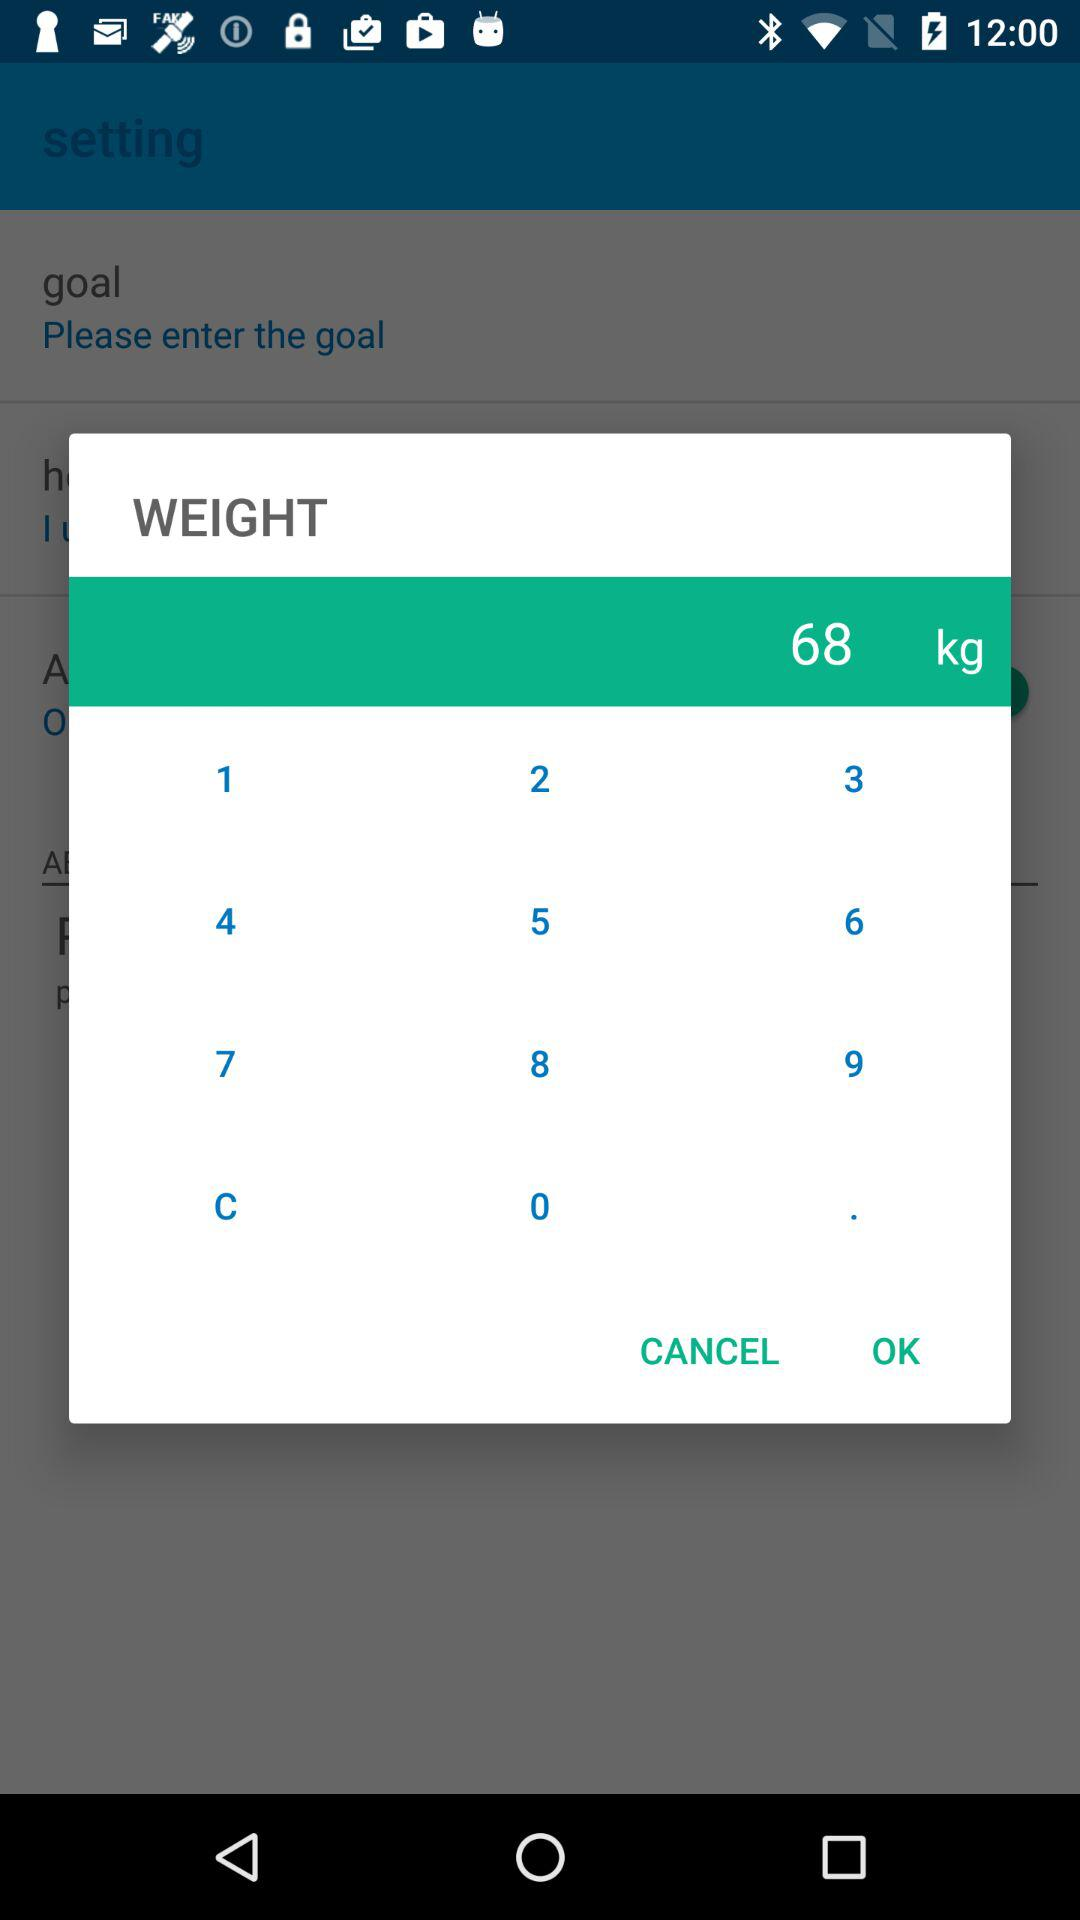What is the entered weight in kilograms? The entered weight in kilograms is 68. 